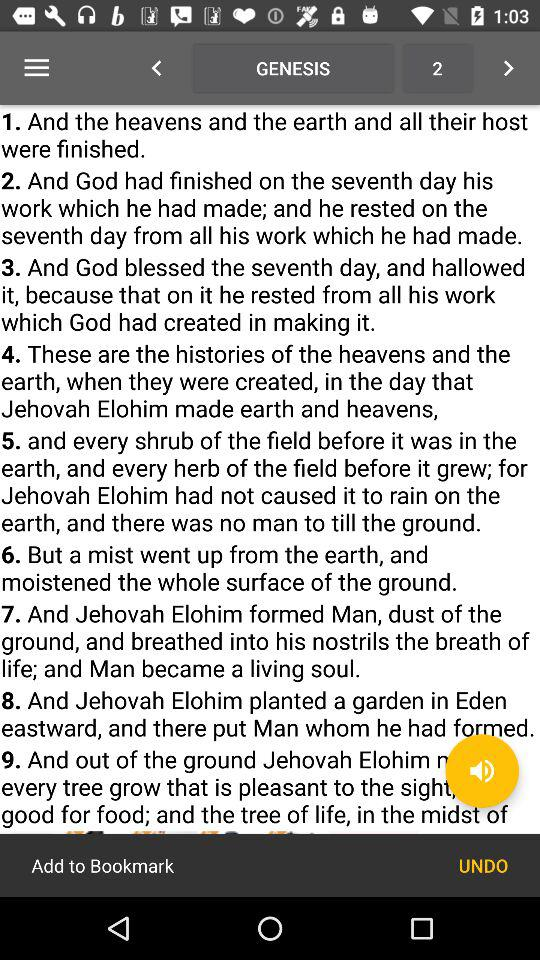How many text blocks are there?
Answer the question using a single word or phrase. 9 